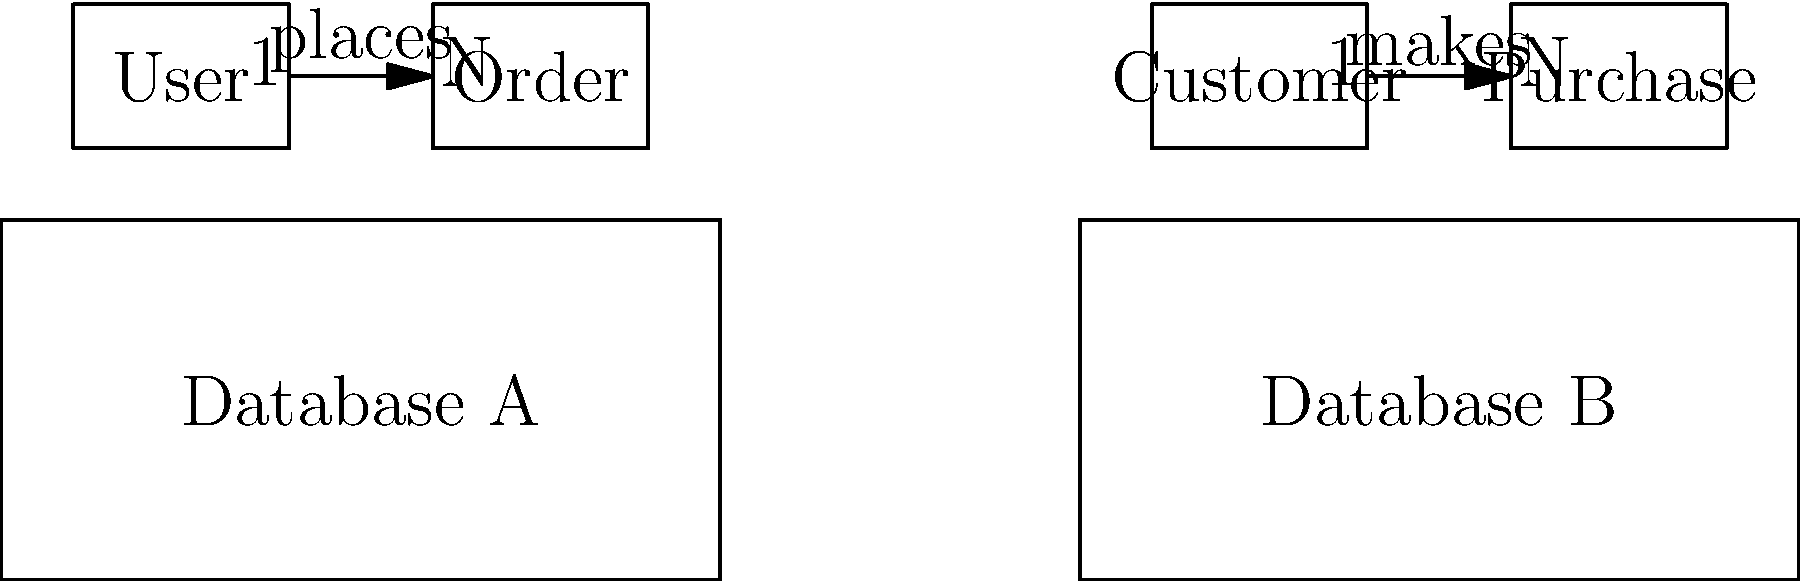In the given entity-relationship diagrams representing two different database schemas (A and B), what is the primary difference in how the two schemas model the relationship between users/customers and their orders/purchases? To answer this question, we need to analyze the entity-relationship diagrams for both database schemas:

1. Database A:
   - Entities: User and Order
   - Relationship: User "places" Order
   - Cardinality: One-to-Many (1:N)

2. Database B:
   - Entities: Customer and Purchase
   - Relationship: Customer "makes" Purchase
   - Cardinality: One-to-Many (1:N)

3. Comparing the schemas:
   - Both schemas represent a similar concept: a person (User/Customer) making multiple orders/purchases.
   - The cardinality is the same in both cases (1:N).
   - The main difference lies in the naming convention used for the entities and relationships.

4. Key difference:
   - Database A uses more generic terms: "User" and "Order"
   - Database B uses more specific terms: "Customer" and "Purchase"

5. Implications:
   - Database A's schema is more flexible and could potentially accommodate various types of users and orders.
   - Database B's schema is more specific to a customer-purchase scenario, which might be more suitable for a retail-oriented system.

The primary difference between the two schemas is the level of specificity in the entity naming, which reflects the potential scope and application of each database design.
Answer: Entity naming specificity: A uses generic terms (User, Order), while B uses specific terms (Customer, Purchase). 